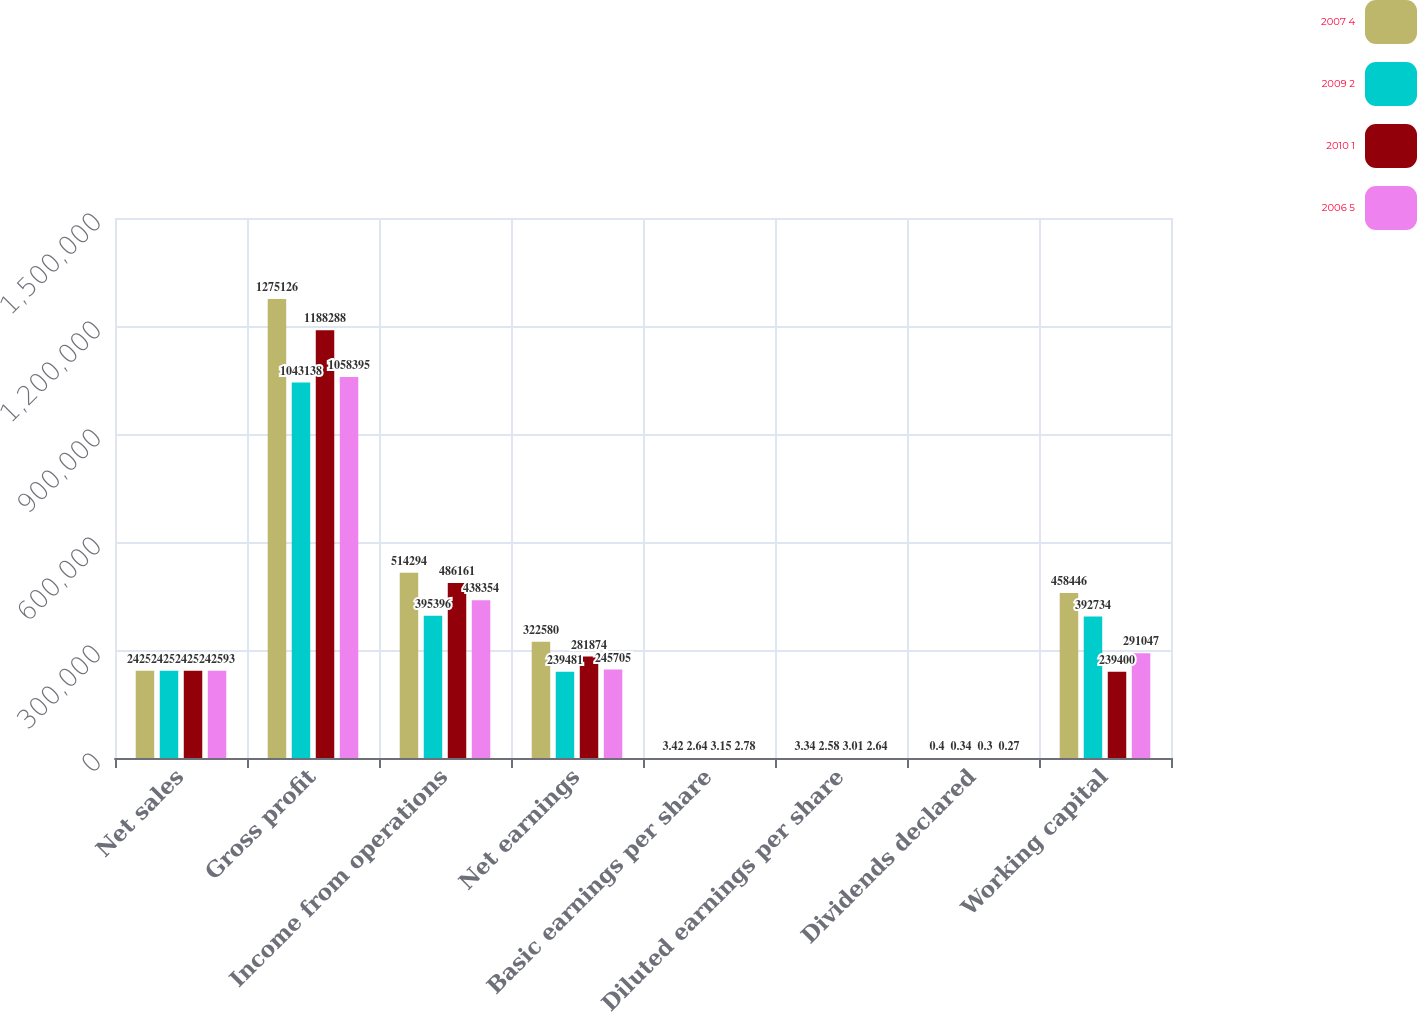Convert chart. <chart><loc_0><loc_0><loc_500><loc_500><stacked_bar_chart><ecel><fcel>Net sales<fcel>Gross profit<fcel>Income from operations<fcel>Net earnings<fcel>Basic earnings per share<fcel>Diluted earnings per share<fcel>Dividends declared<fcel>Working capital<nl><fcel>2007 4<fcel>242593<fcel>1.27513e+06<fcel>514294<fcel>322580<fcel>3.42<fcel>3.34<fcel>0.4<fcel>458446<nl><fcel>2009 2<fcel>242593<fcel>1.04314e+06<fcel>395396<fcel>239481<fcel>2.64<fcel>2.58<fcel>0.34<fcel>392734<nl><fcel>2010 1<fcel>242593<fcel>1.18829e+06<fcel>486161<fcel>281874<fcel>3.15<fcel>3.01<fcel>0.3<fcel>239400<nl><fcel>2006 5<fcel>242593<fcel>1.0584e+06<fcel>438354<fcel>245705<fcel>2.78<fcel>2.64<fcel>0.27<fcel>291047<nl></chart> 